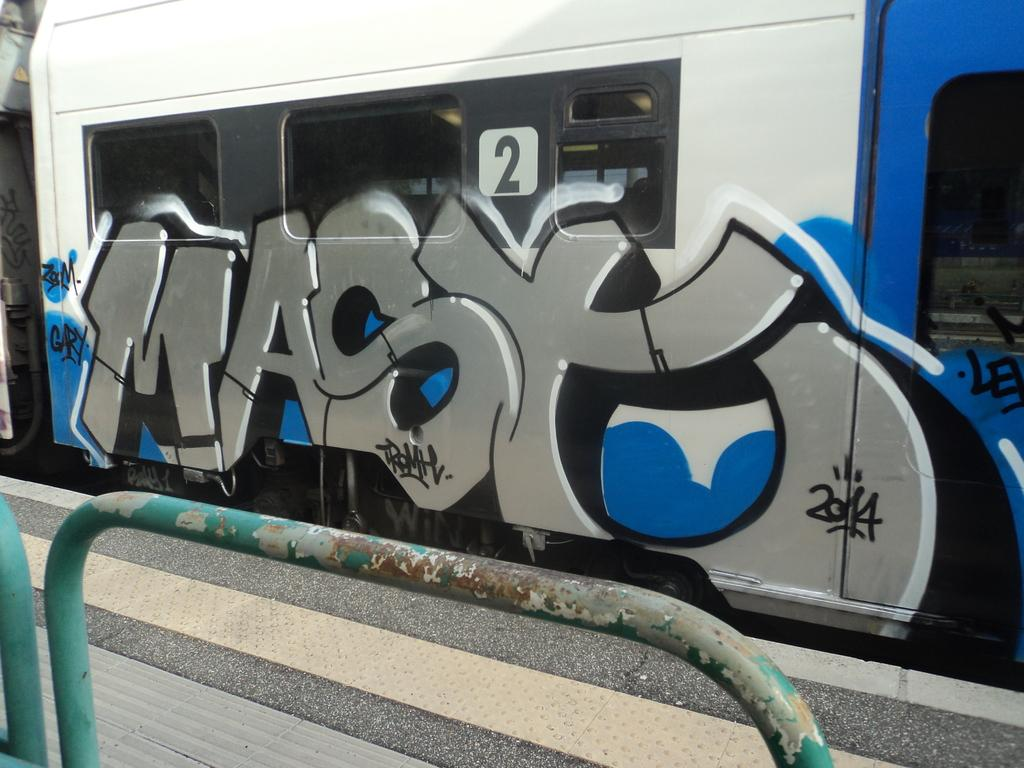What is the main subject of the image? The main subject of the image is a train. Where is the train located in the image? The train is on a railway track. What is present beside the train? There is a platform beside the train. What can be seen at the bottom of the image? There are iron poles at the bottom of the image. What is unique about the train's appearance? The train has a painting on it. What selection of beginner books can be found on the train in the image? There is no mention of books or any selection in the image; it features a train with a painting on it. What discovery was made on the platform beside the train in the image? There is no indication of a discovery or any event taking place on the platform in the image. 